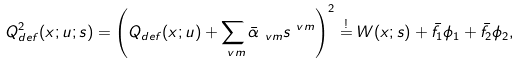<formula> <loc_0><loc_0><loc_500><loc_500>Q _ { d e f } ^ { 2 } ( x ; u ; s ) & = \left ( Q _ { d e f } ( x ; u ) + \sum _ { \ v m } \bar { \alpha } _ { \ v m } s ^ { \ v m } \right ) ^ { 2 } \stackrel { ! } { = } W ( x ; s ) + \bar { f } _ { 1 } \phi _ { 1 } + \bar { f } _ { 2 } \phi _ { 2 } ,</formula> 